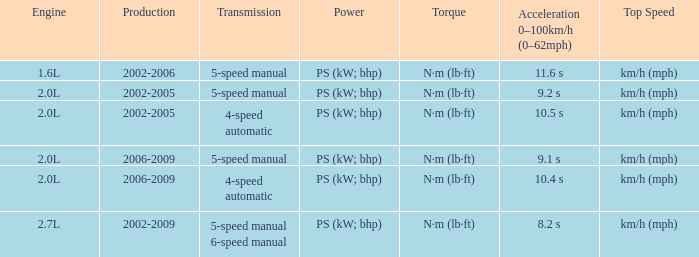What is the acceleration 0-100km/h that was produced in 2002-2006? 11.6 s. 